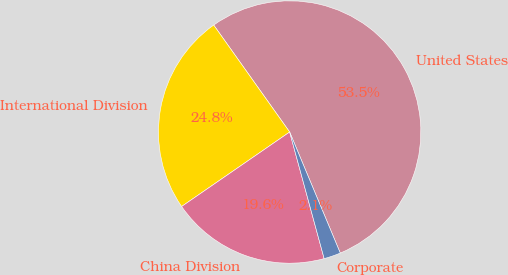<chart> <loc_0><loc_0><loc_500><loc_500><pie_chart><fcel>United States<fcel>International Division<fcel>China Division<fcel>Corporate<nl><fcel>53.52%<fcel>24.78%<fcel>19.63%<fcel>2.07%<nl></chart> 